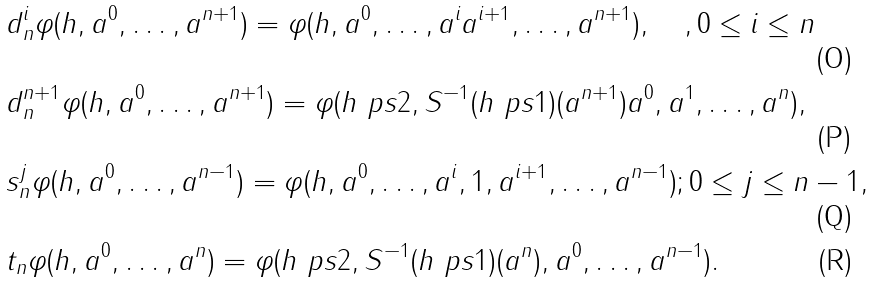<formula> <loc_0><loc_0><loc_500><loc_500>& d _ { n } ^ { i } \varphi ( h , a ^ { 0 } , \dots , a ^ { n + 1 } ) = \varphi ( h , a ^ { 0 } , \dots , a ^ { i } a ^ { i + 1 } , \dots , a ^ { n + 1 } ) , \quad , 0 \leq i \leq n \\ & d _ { n } ^ { n + 1 } \varphi ( h , a ^ { 0 } , \dots , a ^ { n + 1 } ) = \varphi ( h \ p s { 2 } , S ^ { - 1 } ( h \ p s { 1 } ) ( a ^ { n + 1 } ) a ^ { 0 } , a ^ { 1 } , \dots , a ^ { n } ) , \\ & s _ { n } ^ { j } \varphi ( h , a ^ { 0 } , \dots , a ^ { n - 1 } ) = \varphi ( h , a ^ { 0 } , \dots , a ^ { i } , 1 , a ^ { i + 1 } , \dots , a ^ { n - 1 } ) ; 0 \leq j \leq n - 1 , \\ & t _ { n } \varphi ( h , a ^ { 0 } , \dots , a ^ { n } ) = \varphi ( h \ p s { 2 } , S ^ { - 1 } ( h \ p s { 1 } ) ( a ^ { n } ) , a ^ { 0 } , \dots , a ^ { n - 1 } ) .</formula> 